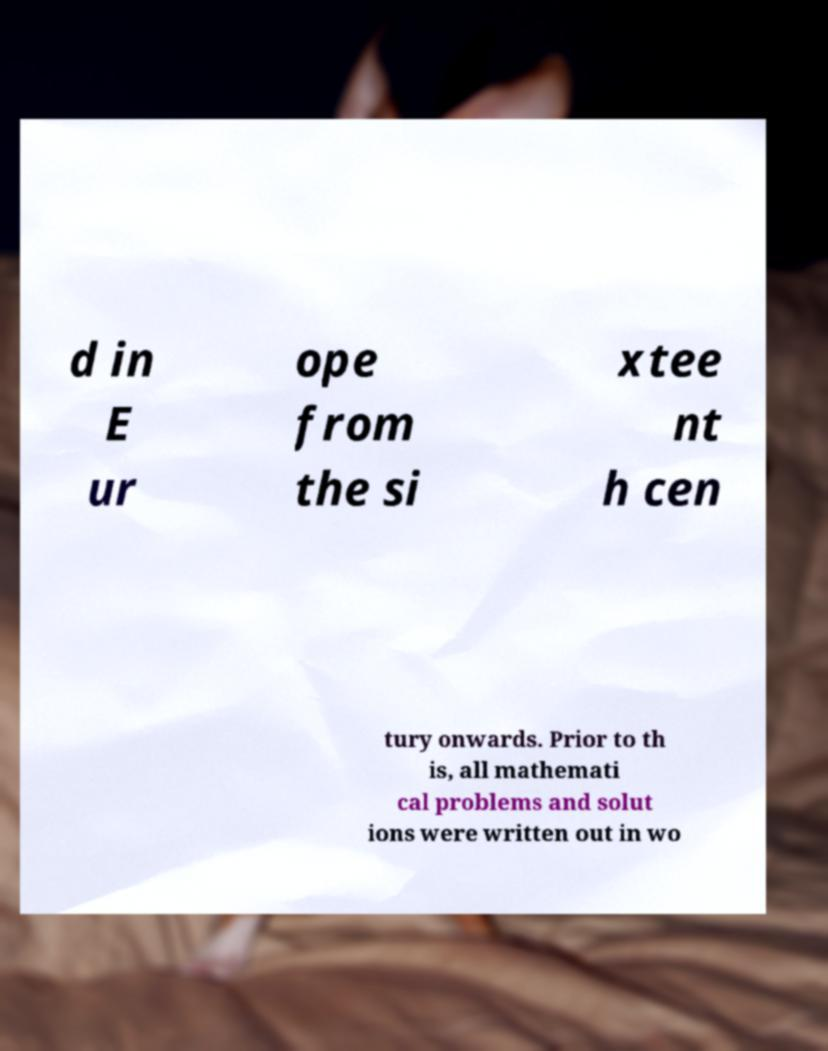Could you extract and type out the text from this image? d in E ur ope from the si xtee nt h cen tury onwards. Prior to th is, all mathemati cal problems and solut ions were written out in wo 